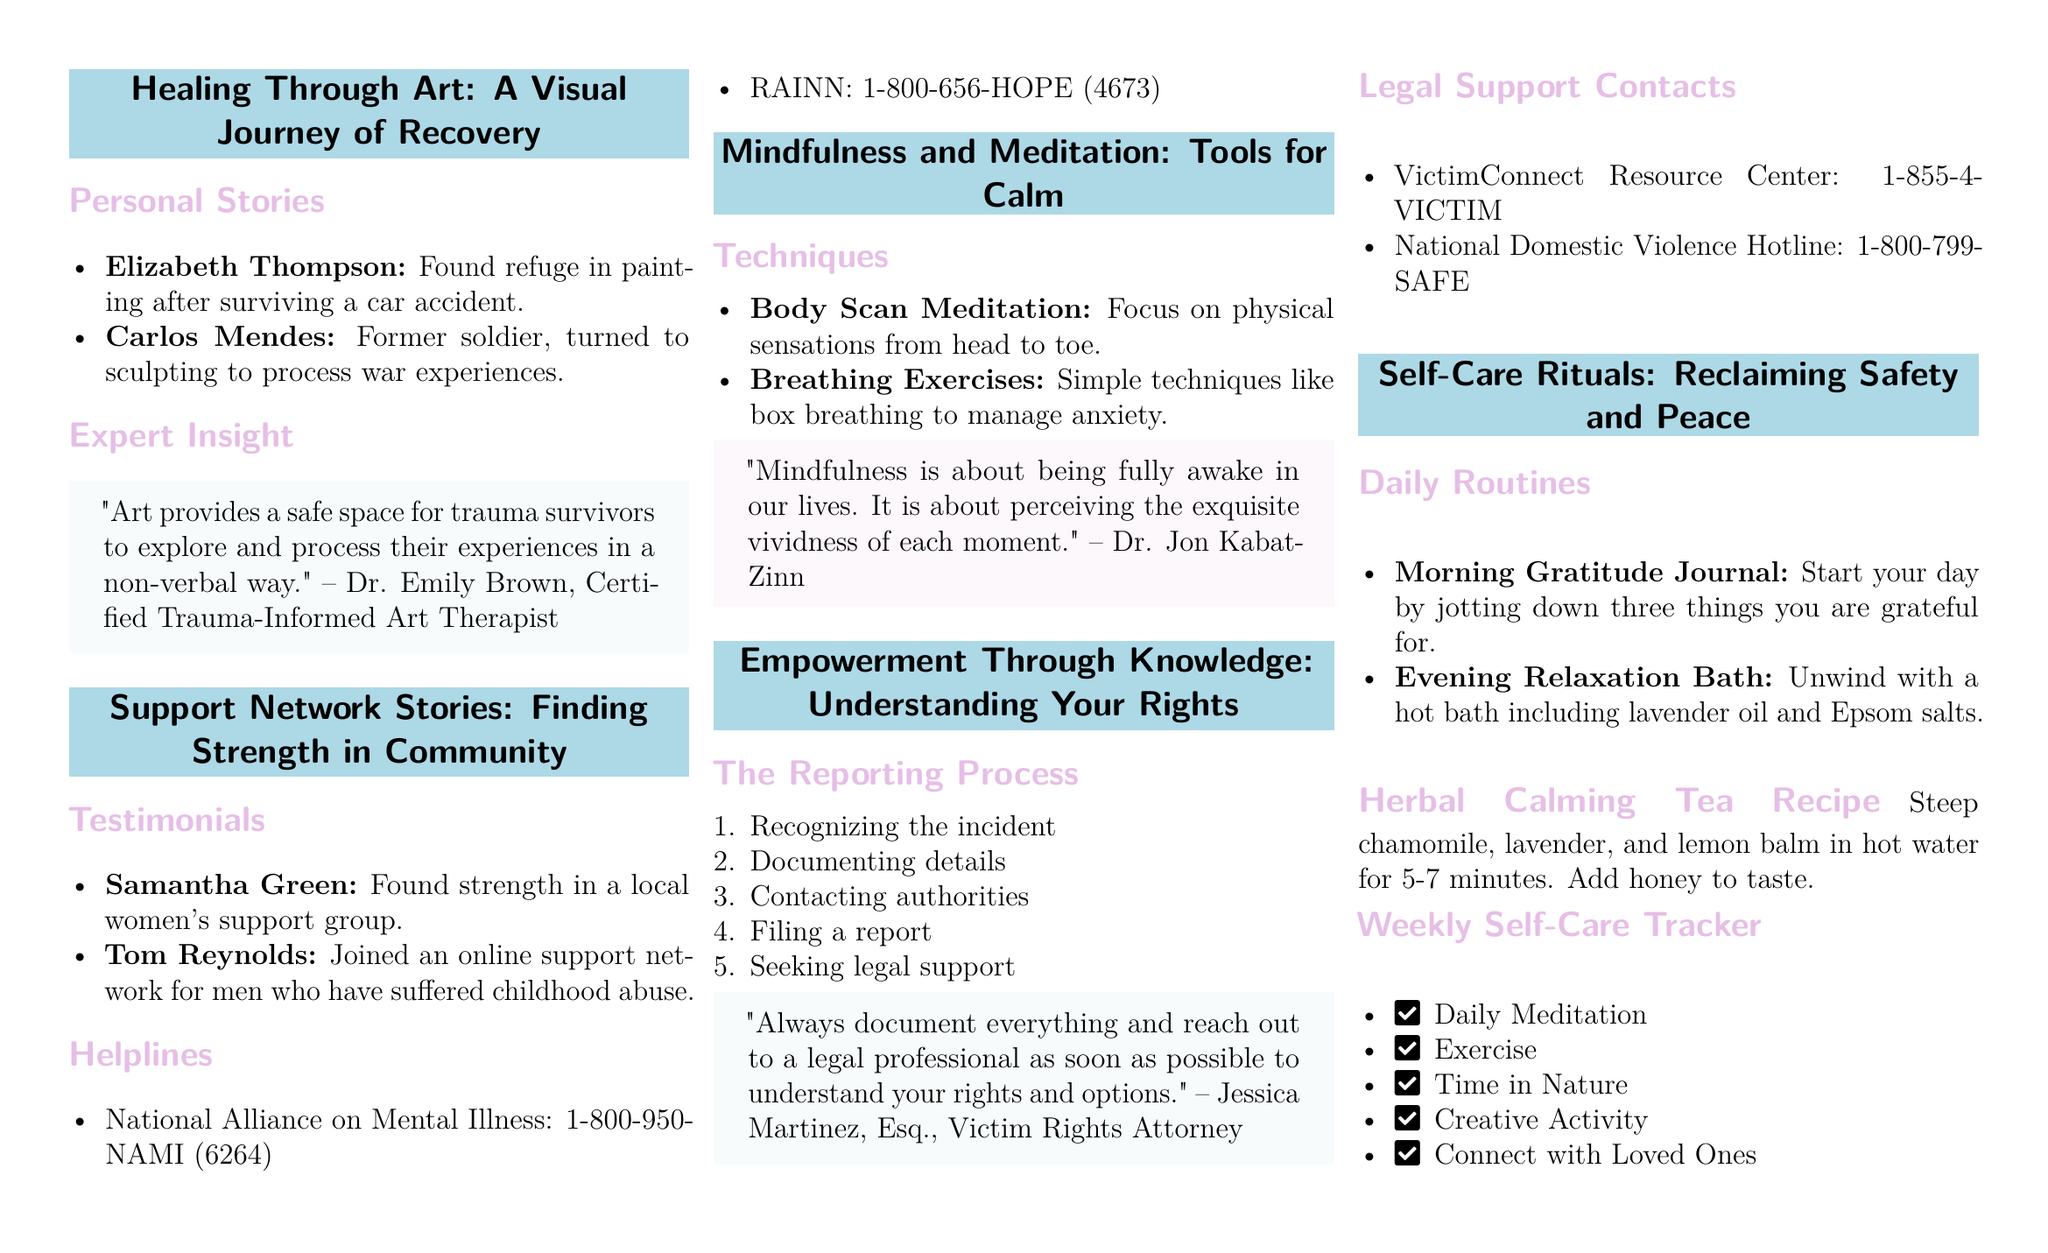what is the full name of the art therapist quoted in the magazine? This information is found in the section titled "Expert Insight." The quote is attributed to Dr. Emily Brown, who is a Certified Trauma-Informed Art Therapist.
Answer: Dr. Emily Brown who is one of the women in the testimonials section? The testimonials are highlighted in "Support Network Stories" and mention Samantha Green as one survivor who found strength in a local women's support group.
Answer: Samantha Green what meditation technique focuses on physical sensations? The document describes "Body Scan Meditation" as a technique in the "Mindfulness and Meditation" section that focuses on physical sensations.
Answer: Body Scan Meditation how many steps are in the reporting process? The reporting process in the "Empowerment Through Knowledge" section consists of five steps.
Answer: 5 what is the calming tea recipe made from? The "Herbal Calming Tea Recipe" includes chamomile, lavender, and lemon balm steeped in hot water.
Answer: chamomile, lavender, lemon balm which support hotline is specifically for domestic violence? The "Legal Support Contacts" section lists the National Domestic Violence Hotline as a resource for those seeking help with domestic violence.
Answer: National Domestic Violence Hotline how can one track their self-care activities? The magazine offers a "Weekly Self-Care Tracker" that allows individuals to check off daily self-care activities like meditation and exercise.
Answer: Weekly Self-Care Tracker who emphasizes the importance of documenting everything? Jessica Martinez, Esq., a Victim Rights Attorney, emphasizes the importance of documentation in the "Empowerment Through Knowledge" section.
Answer: Jessica Martinez what is advised for starting a self-care routine in the morning? The magazine suggests starting the day with a "Morning Gratitude Journal" to focus on gratitude and positivity.
Answer: Morning Gratitude Journal 